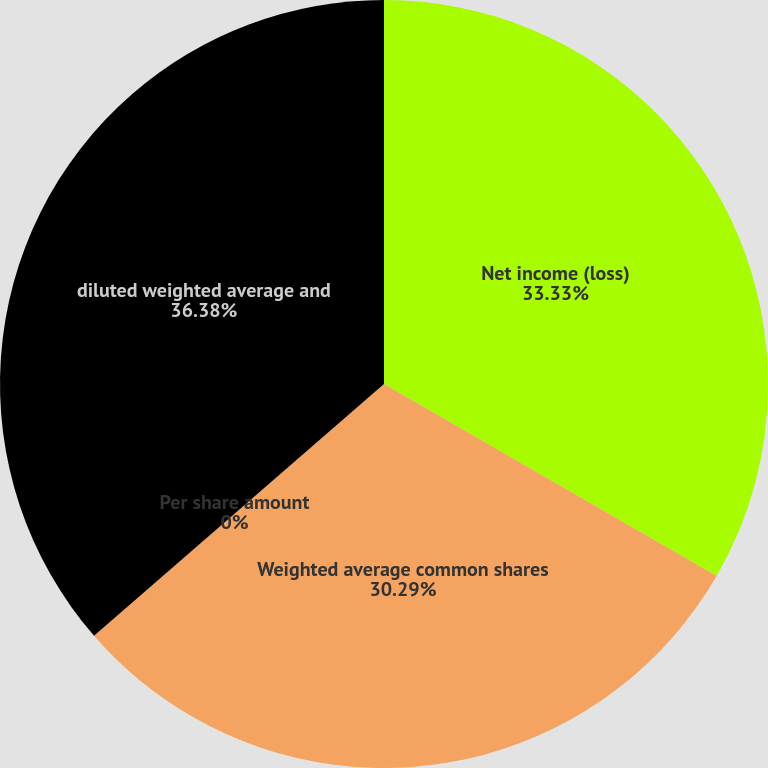<chart> <loc_0><loc_0><loc_500><loc_500><pie_chart><fcel>Net income (loss)<fcel>Weighted average common shares<fcel>Per share amount<fcel>diluted weighted average and<nl><fcel>33.33%<fcel>30.29%<fcel>0.0%<fcel>36.38%<nl></chart> 